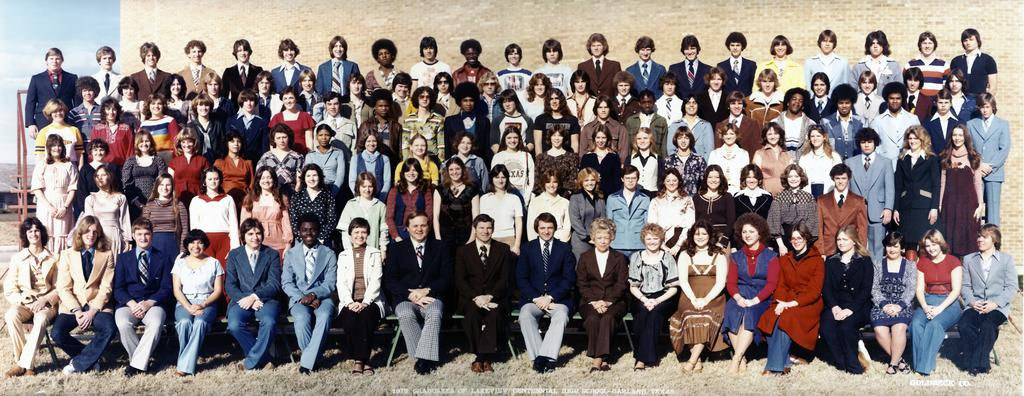What are the people in the image doing? There are people sitting on a bench and standing behind a bench in the image. What are the standing people doing specifically? The standing people are posing for a photograph. What can be seen in the background of the image? There is a wall in the background of the image. How many guitars are visible in the image? There are no guitars present in the image. What type of wealth can be seen in the image? There is no indication of wealth in the image. 